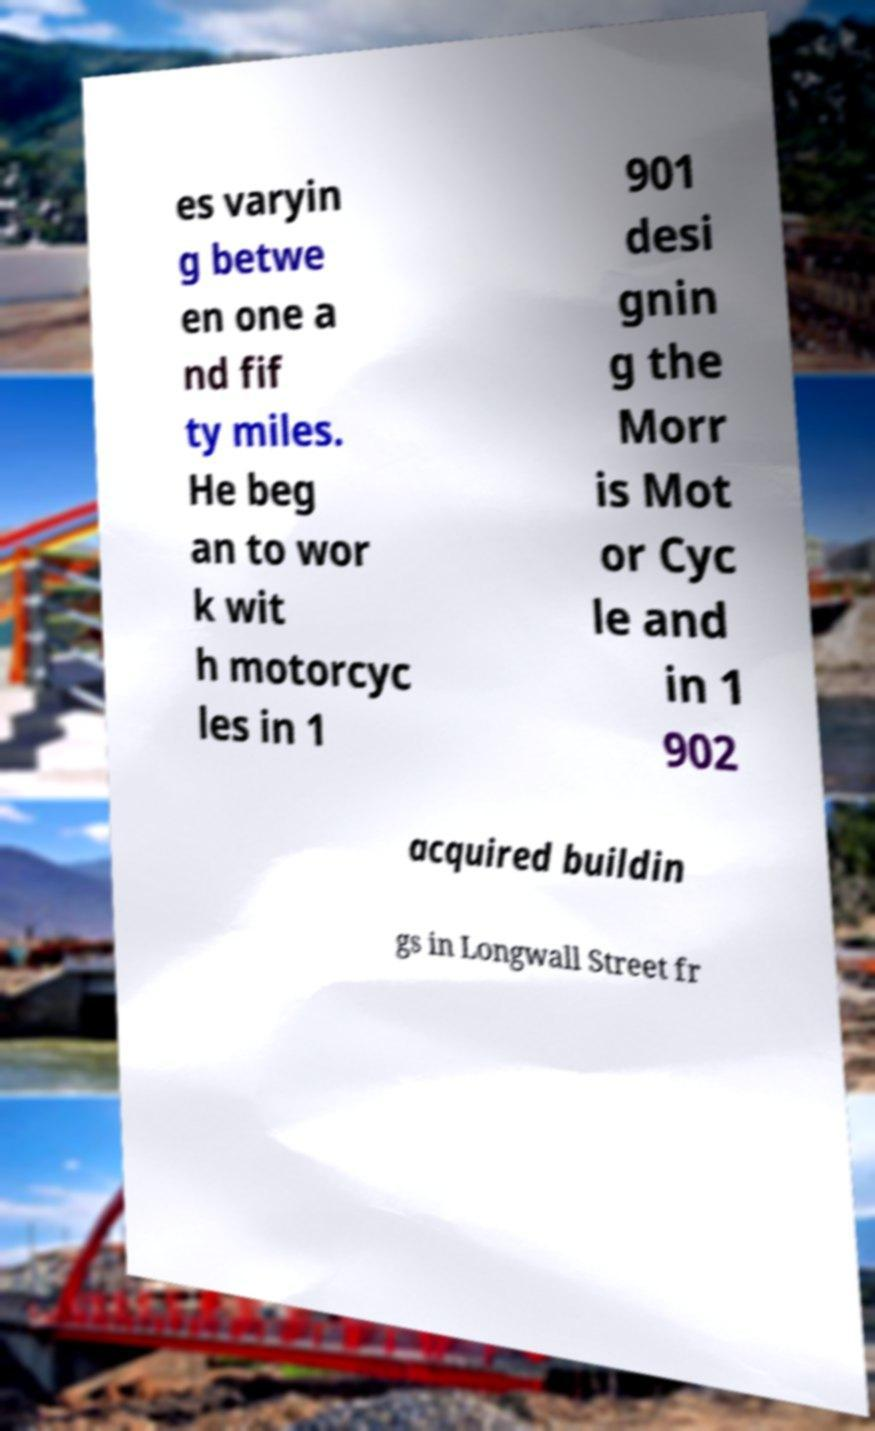Could you assist in decoding the text presented in this image and type it out clearly? es varyin g betwe en one a nd fif ty miles. He beg an to wor k wit h motorcyc les in 1 901 desi gnin g the Morr is Mot or Cyc le and in 1 902 acquired buildin gs in Longwall Street fr 